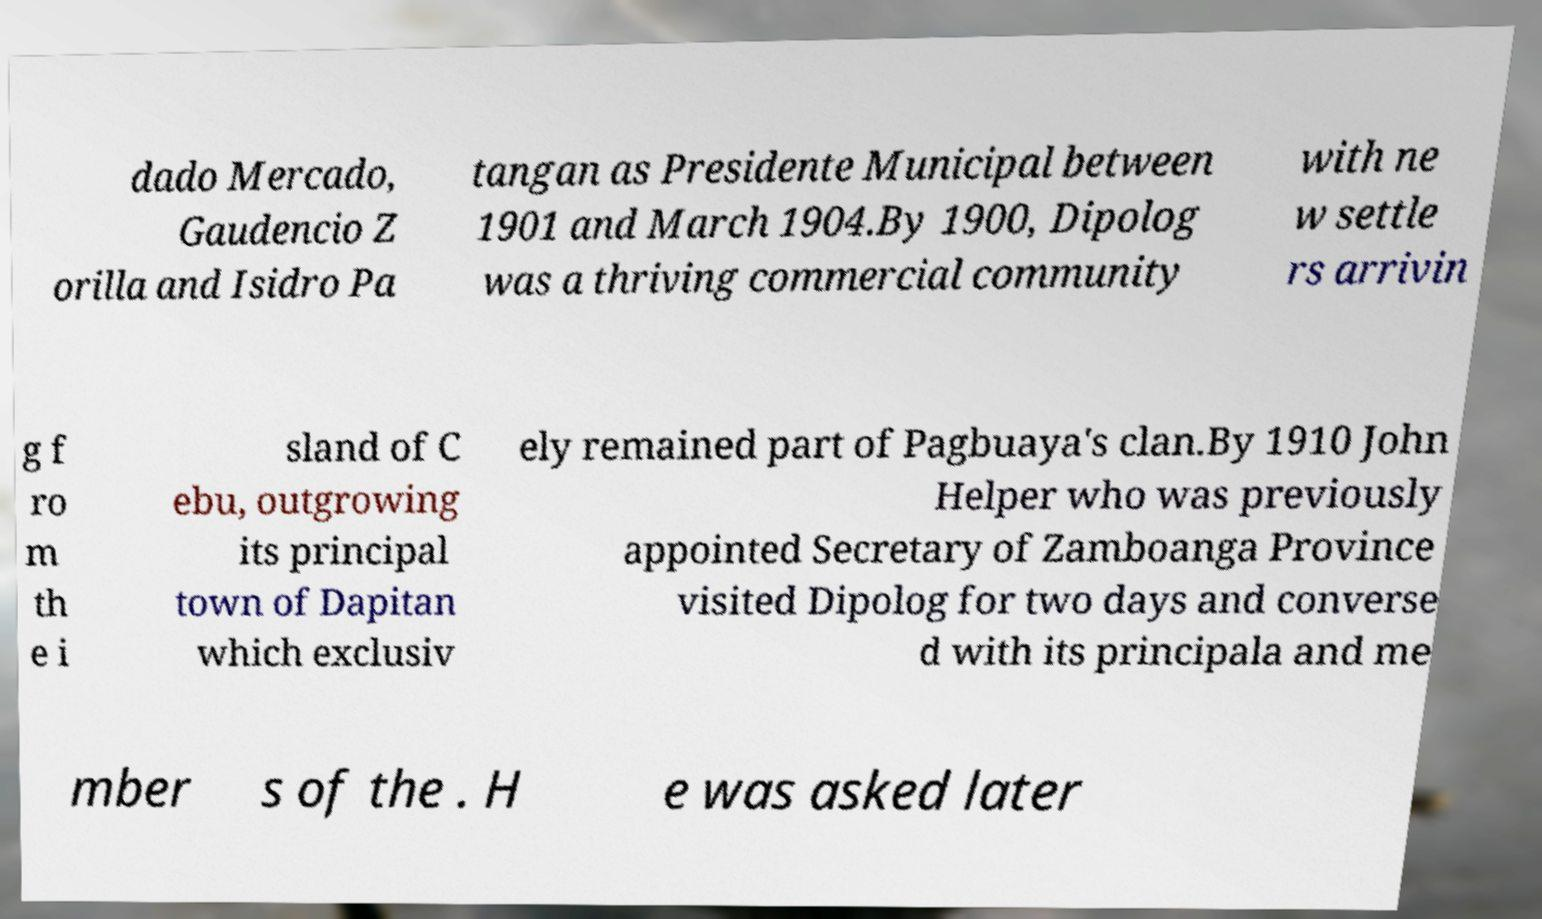Please read and relay the text visible in this image. What does it say? dado Mercado, Gaudencio Z orilla and Isidro Pa tangan as Presidente Municipal between 1901 and March 1904.By 1900, Dipolog was a thriving commercial community with ne w settle rs arrivin g f ro m th e i sland of C ebu, outgrowing its principal town of Dapitan which exclusiv ely remained part of Pagbuaya's clan.By 1910 John Helper who was previously appointed Secretary of Zamboanga Province visited Dipolog for two days and converse d with its principala and me mber s of the . H e was asked later 